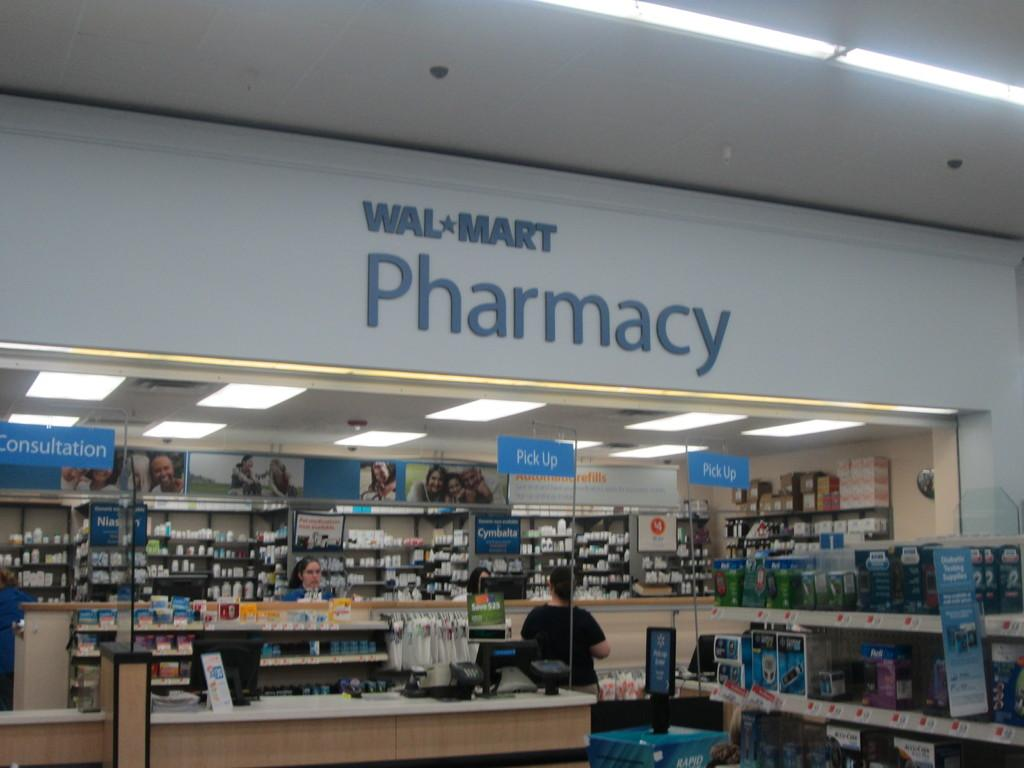<image>
Write a terse but informative summary of the picture. A woman inside the Walmart Pharmacy by the pick up sign. 